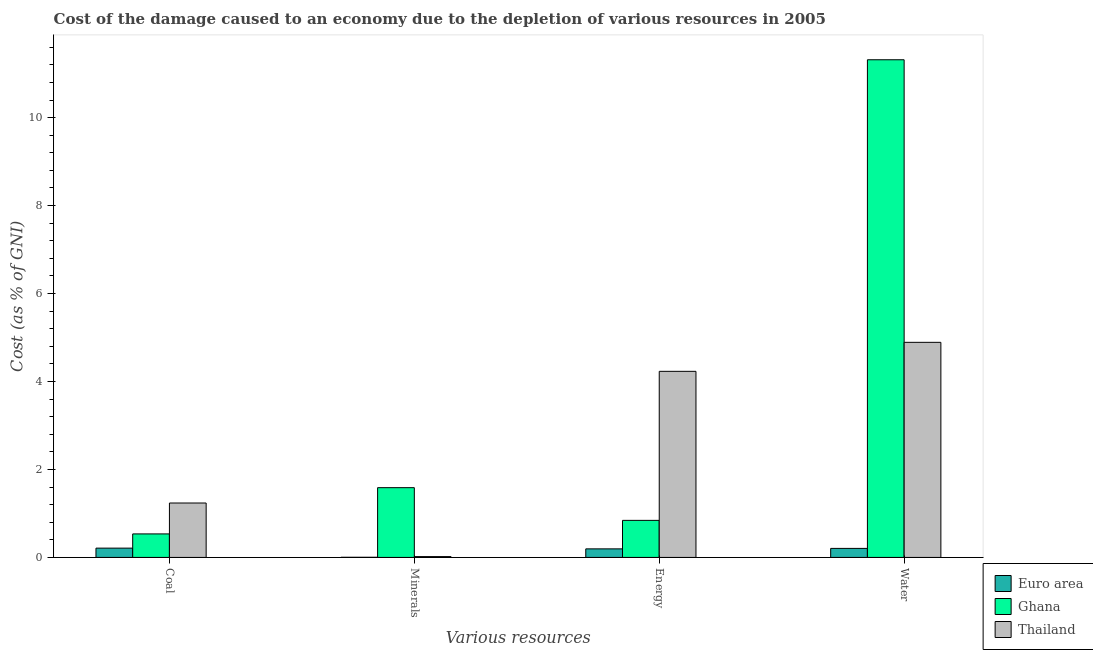How many different coloured bars are there?
Provide a short and direct response. 3. How many groups of bars are there?
Your answer should be compact. 4. Are the number of bars per tick equal to the number of legend labels?
Offer a terse response. Yes. How many bars are there on the 4th tick from the left?
Your response must be concise. 3. What is the label of the 3rd group of bars from the left?
Provide a short and direct response. Energy. What is the cost of damage due to depletion of water in Thailand?
Your answer should be very brief. 4.89. Across all countries, what is the maximum cost of damage due to depletion of energy?
Give a very brief answer. 4.23. Across all countries, what is the minimum cost of damage due to depletion of coal?
Your response must be concise. 0.21. What is the total cost of damage due to depletion of energy in the graph?
Make the answer very short. 5.27. What is the difference between the cost of damage due to depletion of coal in Euro area and that in Ghana?
Your response must be concise. -0.32. What is the difference between the cost of damage due to depletion of water in Thailand and the cost of damage due to depletion of minerals in Euro area?
Provide a short and direct response. 4.89. What is the average cost of damage due to depletion of energy per country?
Keep it short and to the point. 1.76. What is the difference between the cost of damage due to depletion of water and cost of damage due to depletion of energy in Ghana?
Your response must be concise. 10.47. What is the ratio of the cost of damage due to depletion of energy in Euro area to that in Ghana?
Offer a very short reply. 0.23. What is the difference between the highest and the second highest cost of damage due to depletion of water?
Keep it short and to the point. 6.42. What is the difference between the highest and the lowest cost of damage due to depletion of energy?
Offer a very short reply. 4.04. In how many countries, is the cost of damage due to depletion of energy greater than the average cost of damage due to depletion of energy taken over all countries?
Give a very brief answer. 1. Is it the case that in every country, the sum of the cost of damage due to depletion of coal and cost of damage due to depletion of minerals is greater than the sum of cost of damage due to depletion of energy and cost of damage due to depletion of water?
Keep it short and to the point. No. What does the 3rd bar from the right in Coal represents?
Your response must be concise. Euro area. Is it the case that in every country, the sum of the cost of damage due to depletion of coal and cost of damage due to depletion of minerals is greater than the cost of damage due to depletion of energy?
Make the answer very short. No. How many bars are there?
Keep it short and to the point. 12. Are all the bars in the graph horizontal?
Offer a terse response. No. How many countries are there in the graph?
Your answer should be very brief. 3. Are the values on the major ticks of Y-axis written in scientific E-notation?
Your response must be concise. No. Does the graph contain any zero values?
Make the answer very short. No. How many legend labels are there?
Offer a terse response. 3. What is the title of the graph?
Provide a short and direct response. Cost of the damage caused to an economy due to the depletion of various resources in 2005 . What is the label or title of the X-axis?
Give a very brief answer. Various resources. What is the label or title of the Y-axis?
Offer a very short reply. Cost (as % of GNI). What is the Cost (as % of GNI) of Euro area in Coal?
Provide a succinct answer. 0.21. What is the Cost (as % of GNI) in Ghana in Coal?
Give a very brief answer. 0.53. What is the Cost (as % of GNI) in Thailand in Coal?
Provide a succinct answer. 1.24. What is the Cost (as % of GNI) in Euro area in Minerals?
Your answer should be very brief. 0. What is the Cost (as % of GNI) in Ghana in Minerals?
Ensure brevity in your answer.  1.59. What is the Cost (as % of GNI) in Thailand in Minerals?
Your response must be concise. 0.02. What is the Cost (as % of GNI) in Euro area in Energy?
Your answer should be very brief. 0.19. What is the Cost (as % of GNI) in Ghana in Energy?
Provide a succinct answer. 0.84. What is the Cost (as % of GNI) in Thailand in Energy?
Your response must be concise. 4.23. What is the Cost (as % of GNI) of Euro area in Water?
Keep it short and to the point. 0.21. What is the Cost (as % of GNI) of Ghana in Water?
Offer a terse response. 11.32. What is the Cost (as % of GNI) in Thailand in Water?
Provide a short and direct response. 4.89. Across all Various resources, what is the maximum Cost (as % of GNI) of Euro area?
Keep it short and to the point. 0.21. Across all Various resources, what is the maximum Cost (as % of GNI) in Ghana?
Ensure brevity in your answer.  11.32. Across all Various resources, what is the maximum Cost (as % of GNI) of Thailand?
Keep it short and to the point. 4.89. Across all Various resources, what is the minimum Cost (as % of GNI) of Euro area?
Provide a succinct answer. 0. Across all Various resources, what is the minimum Cost (as % of GNI) of Ghana?
Provide a short and direct response. 0.53. Across all Various resources, what is the minimum Cost (as % of GNI) in Thailand?
Offer a terse response. 0.02. What is the total Cost (as % of GNI) of Euro area in the graph?
Provide a succinct answer. 0.61. What is the total Cost (as % of GNI) of Ghana in the graph?
Your answer should be compact. 14.28. What is the total Cost (as % of GNI) of Thailand in the graph?
Your answer should be very brief. 10.38. What is the difference between the Cost (as % of GNI) of Euro area in Coal and that in Minerals?
Provide a succinct answer. 0.21. What is the difference between the Cost (as % of GNI) in Ghana in Coal and that in Minerals?
Ensure brevity in your answer.  -1.05. What is the difference between the Cost (as % of GNI) of Thailand in Coal and that in Minerals?
Keep it short and to the point. 1.22. What is the difference between the Cost (as % of GNI) of Euro area in Coal and that in Energy?
Provide a short and direct response. 0.02. What is the difference between the Cost (as % of GNI) of Ghana in Coal and that in Energy?
Your answer should be very brief. -0.31. What is the difference between the Cost (as % of GNI) of Thailand in Coal and that in Energy?
Your answer should be compact. -2.99. What is the difference between the Cost (as % of GNI) of Euro area in Coal and that in Water?
Keep it short and to the point. 0.01. What is the difference between the Cost (as % of GNI) of Ghana in Coal and that in Water?
Provide a succinct answer. -10.78. What is the difference between the Cost (as % of GNI) in Thailand in Coal and that in Water?
Make the answer very short. -3.65. What is the difference between the Cost (as % of GNI) of Euro area in Minerals and that in Energy?
Your answer should be very brief. -0.19. What is the difference between the Cost (as % of GNI) of Ghana in Minerals and that in Energy?
Give a very brief answer. 0.74. What is the difference between the Cost (as % of GNI) in Thailand in Minerals and that in Energy?
Provide a short and direct response. -4.21. What is the difference between the Cost (as % of GNI) in Euro area in Minerals and that in Water?
Provide a succinct answer. -0.2. What is the difference between the Cost (as % of GNI) in Ghana in Minerals and that in Water?
Provide a succinct answer. -9.73. What is the difference between the Cost (as % of GNI) of Thailand in Minerals and that in Water?
Ensure brevity in your answer.  -4.87. What is the difference between the Cost (as % of GNI) of Euro area in Energy and that in Water?
Your answer should be compact. -0.01. What is the difference between the Cost (as % of GNI) in Ghana in Energy and that in Water?
Offer a very short reply. -10.47. What is the difference between the Cost (as % of GNI) in Thailand in Energy and that in Water?
Your answer should be compact. -0.66. What is the difference between the Cost (as % of GNI) of Euro area in Coal and the Cost (as % of GNI) of Ghana in Minerals?
Provide a short and direct response. -1.37. What is the difference between the Cost (as % of GNI) of Euro area in Coal and the Cost (as % of GNI) of Thailand in Minerals?
Your answer should be compact. 0.19. What is the difference between the Cost (as % of GNI) of Ghana in Coal and the Cost (as % of GNI) of Thailand in Minerals?
Give a very brief answer. 0.52. What is the difference between the Cost (as % of GNI) of Euro area in Coal and the Cost (as % of GNI) of Ghana in Energy?
Your answer should be very brief. -0.63. What is the difference between the Cost (as % of GNI) in Euro area in Coal and the Cost (as % of GNI) in Thailand in Energy?
Give a very brief answer. -4.02. What is the difference between the Cost (as % of GNI) of Ghana in Coal and the Cost (as % of GNI) of Thailand in Energy?
Offer a very short reply. -3.7. What is the difference between the Cost (as % of GNI) in Euro area in Coal and the Cost (as % of GNI) in Ghana in Water?
Make the answer very short. -11.1. What is the difference between the Cost (as % of GNI) in Euro area in Coal and the Cost (as % of GNI) in Thailand in Water?
Offer a very short reply. -4.68. What is the difference between the Cost (as % of GNI) in Ghana in Coal and the Cost (as % of GNI) in Thailand in Water?
Provide a succinct answer. -4.36. What is the difference between the Cost (as % of GNI) in Euro area in Minerals and the Cost (as % of GNI) in Ghana in Energy?
Offer a very short reply. -0.84. What is the difference between the Cost (as % of GNI) of Euro area in Minerals and the Cost (as % of GNI) of Thailand in Energy?
Your response must be concise. -4.23. What is the difference between the Cost (as % of GNI) of Ghana in Minerals and the Cost (as % of GNI) of Thailand in Energy?
Offer a terse response. -2.64. What is the difference between the Cost (as % of GNI) in Euro area in Minerals and the Cost (as % of GNI) in Ghana in Water?
Make the answer very short. -11.31. What is the difference between the Cost (as % of GNI) in Euro area in Minerals and the Cost (as % of GNI) in Thailand in Water?
Give a very brief answer. -4.89. What is the difference between the Cost (as % of GNI) in Ghana in Minerals and the Cost (as % of GNI) in Thailand in Water?
Provide a succinct answer. -3.3. What is the difference between the Cost (as % of GNI) of Euro area in Energy and the Cost (as % of GNI) of Ghana in Water?
Make the answer very short. -11.12. What is the difference between the Cost (as % of GNI) in Euro area in Energy and the Cost (as % of GNI) in Thailand in Water?
Keep it short and to the point. -4.7. What is the difference between the Cost (as % of GNI) of Ghana in Energy and the Cost (as % of GNI) of Thailand in Water?
Make the answer very short. -4.05. What is the average Cost (as % of GNI) of Euro area per Various resources?
Offer a terse response. 0.15. What is the average Cost (as % of GNI) in Ghana per Various resources?
Ensure brevity in your answer.  3.57. What is the average Cost (as % of GNI) in Thailand per Various resources?
Provide a short and direct response. 2.59. What is the difference between the Cost (as % of GNI) of Euro area and Cost (as % of GNI) of Ghana in Coal?
Your answer should be very brief. -0.32. What is the difference between the Cost (as % of GNI) in Euro area and Cost (as % of GNI) in Thailand in Coal?
Offer a terse response. -1.03. What is the difference between the Cost (as % of GNI) of Ghana and Cost (as % of GNI) of Thailand in Coal?
Your answer should be very brief. -0.7. What is the difference between the Cost (as % of GNI) in Euro area and Cost (as % of GNI) in Ghana in Minerals?
Make the answer very short. -1.58. What is the difference between the Cost (as % of GNI) in Euro area and Cost (as % of GNI) in Thailand in Minerals?
Offer a very short reply. -0.02. What is the difference between the Cost (as % of GNI) in Ghana and Cost (as % of GNI) in Thailand in Minerals?
Offer a terse response. 1.57. What is the difference between the Cost (as % of GNI) of Euro area and Cost (as % of GNI) of Ghana in Energy?
Your answer should be compact. -0.65. What is the difference between the Cost (as % of GNI) in Euro area and Cost (as % of GNI) in Thailand in Energy?
Offer a very short reply. -4.04. What is the difference between the Cost (as % of GNI) in Ghana and Cost (as % of GNI) in Thailand in Energy?
Ensure brevity in your answer.  -3.39. What is the difference between the Cost (as % of GNI) in Euro area and Cost (as % of GNI) in Ghana in Water?
Offer a terse response. -11.11. What is the difference between the Cost (as % of GNI) of Euro area and Cost (as % of GNI) of Thailand in Water?
Ensure brevity in your answer.  -4.69. What is the difference between the Cost (as % of GNI) of Ghana and Cost (as % of GNI) of Thailand in Water?
Keep it short and to the point. 6.42. What is the ratio of the Cost (as % of GNI) of Euro area in Coal to that in Minerals?
Give a very brief answer. 67.3. What is the ratio of the Cost (as % of GNI) of Ghana in Coal to that in Minerals?
Ensure brevity in your answer.  0.34. What is the ratio of the Cost (as % of GNI) in Thailand in Coal to that in Minerals?
Provide a succinct answer. 65.4. What is the ratio of the Cost (as % of GNI) in Euro area in Coal to that in Energy?
Give a very brief answer. 1.08. What is the ratio of the Cost (as % of GNI) in Ghana in Coal to that in Energy?
Offer a terse response. 0.63. What is the ratio of the Cost (as % of GNI) in Thailand in Coal to that in Energy?
Give a very brief answer. 0.29. What is the ratio of the Cost (as % of GNI) in Euro area in Coal to that in Water?
Provide a short and direct response. 1.03. What is the ratio of the Cost (as % of GNI) in Ghana in Coal to that in Water?
Make the answer very short. 0.05. What is the ratio of the Cost (as % of GNI) in Thailand in Coal to that in Water?
Make the answer very short. 0.25. What is the ratio of the Cost (as % of GNI) in Euro area in Minerals to that in Energy?
Provide a short and direct response. 0.02. What is the ratio of the Cost (as % of GNI) in Ghana in Minerals to that in Energy?
Offer a very short reply. 1.88. What is the ratio of the Cost (as % of GNI) of Thailand in Minerals to that in Energy?
Give a very brief answer. 0. What is the ratio of the Cost (as % of GNI) in Euro area in Minerals to that in Water?
Offer a very short reply. 0.02. What is the ratio of the Cost (as % of GNI) of Ghana in Minerals to that in Water?
Your answer should be compact. 0.14. What is the ratio of the Cost (as % of GNI) of Thailand in Minerals to that in Water?
Offer a very short reply. 0. What is the ratio of the Cost (as % of GNI) of Euro area in Energy to that in Water?
Make the answer very short. 0.95. What is the ratio of the Cost (as % of GNI) in Ghana in Energy to that in Water?
Your response must be concise. 0.07. What is the ratio of the Cost (as % of GNI) of Thailand in Energy to that in Water?
Provide a short and direct response. 0.87. What is the difference between the highest and the second highest Cost (as % of GNI) of Euro area?
Give a very brief answer. 0.01. What is the difference between the highest and the second highest Cost (as % of GNI) in Ghana?
Offer a very short reply. 9.73. What is the difference between the highest and the second highest Cost (as % of GNI) in Thailand?
Your answer should be compact. 0.66. What is the difference between the highest and the lowest Cost (as % of GNI) of Euro area?
Provide a succinct answer. 0.21. What is the difference between the highest and the lowest Cost (as % of GNI) of Ghana?
Your answer should be very brief. 10.78. What is the difference between the highest and the lowest Cost (as % of GNI) in Thailand?
Offer a very short reply. 4.87. 